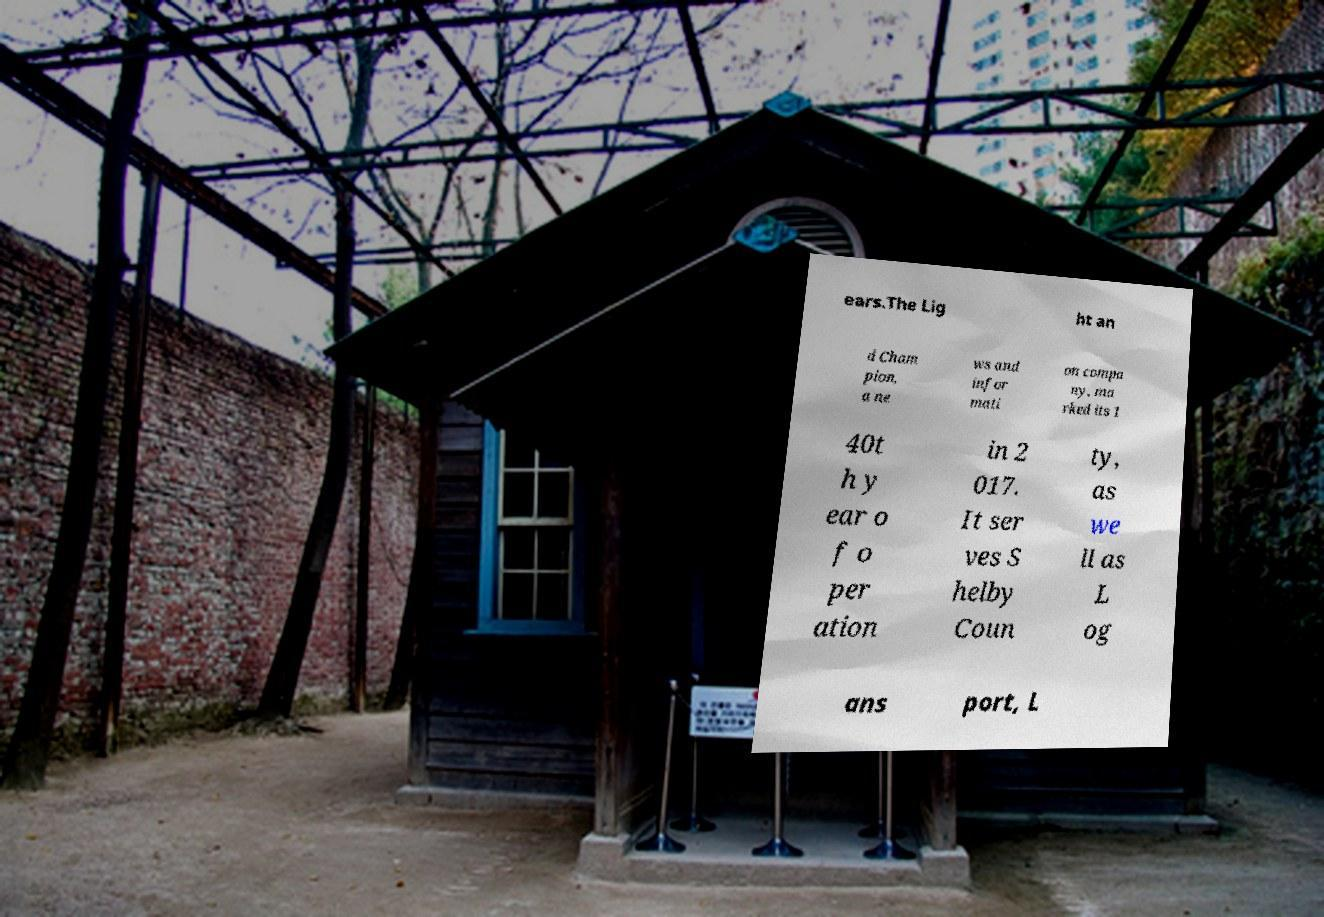Could you extract and type out the text from this image? ears.The Lig ht an d Cham pion, a ne ws and infor mati on compa ny, ma rked its 1 40t h y ear o f o per ation in 2 017. It ser ves S helby Coun ty, as we ll as L og ans port, L 